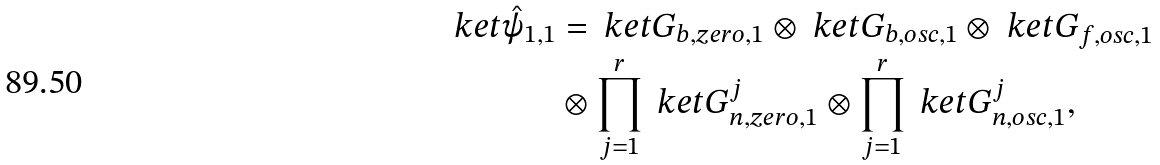<formula> <loc_0><loc_0><loc_500><loc_500>\ k e t { \hat { \psi } _ { 1 , 1 } } & = \ k e t { G _ { b , z e r o , 1 } } \otimes \ k e t { G _ { b , o s c , 1 } } \otimes \ k e t { G _ { f , o s c , 1 } } \\ & \otimes \prod _ { j = 1 } ^ { r } \ k e t { G _ { n , z e r o , 1 } ^ { j } } \otimes \prod _ { j = 1 } ^ { r } \ k e t { G _ { n , o s c , 1 } ^ { j } } ,</formula> 